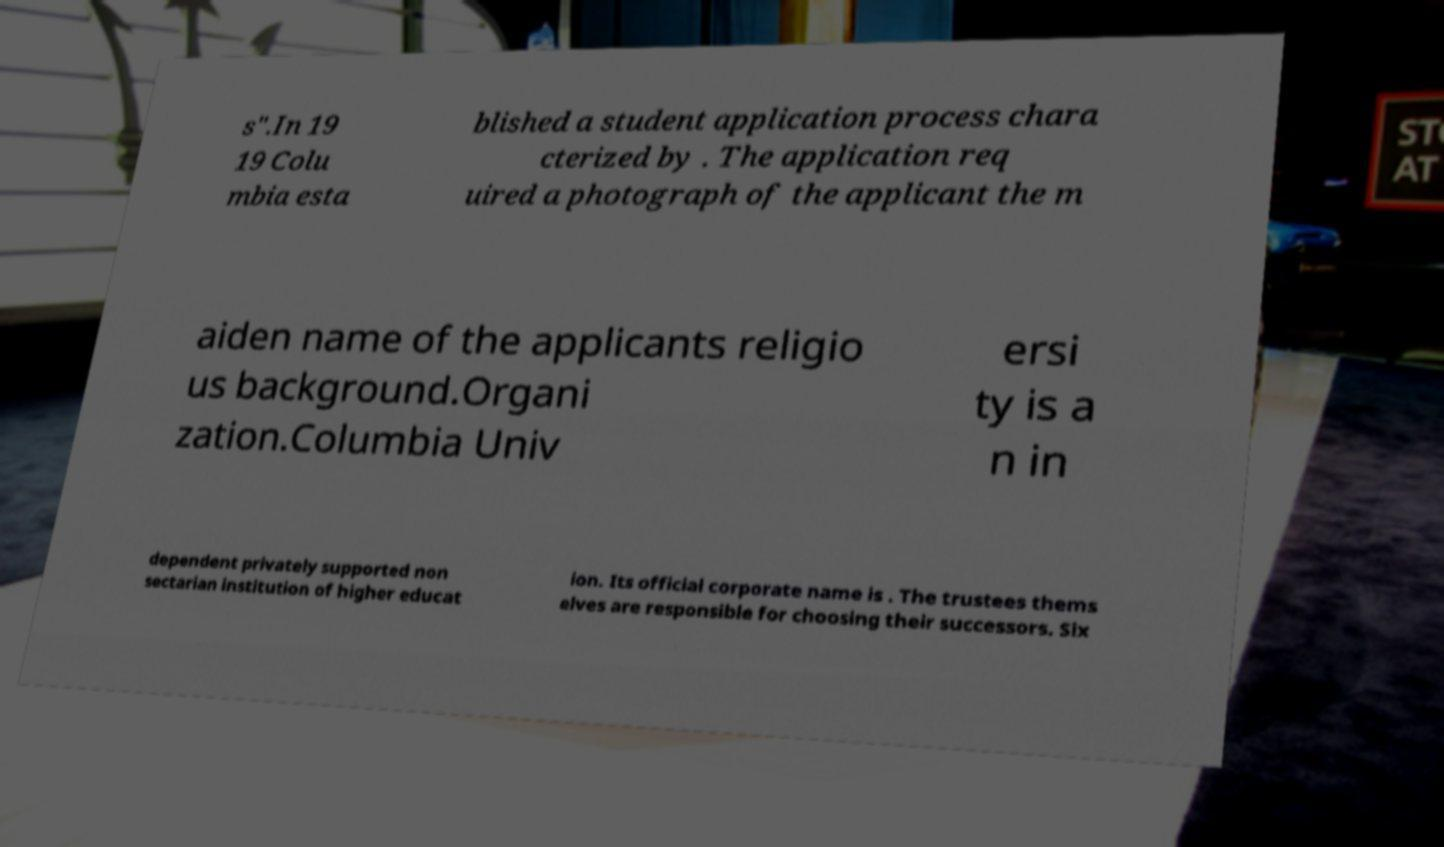Please identify and transcribe the text found in this image. s".In 19 19 Colu mbia esta blished a student application process chara cterized by . The application req uired a photograph of the applicant the m aiden name of the applicants religio us background.Organi zation.Columbia Univ ersi ty is a n in dependent privately supported non sectarian institution of higher educat ion. Its official corporate name is . The trustees thems elves are responsible for choosing their successors. Six 